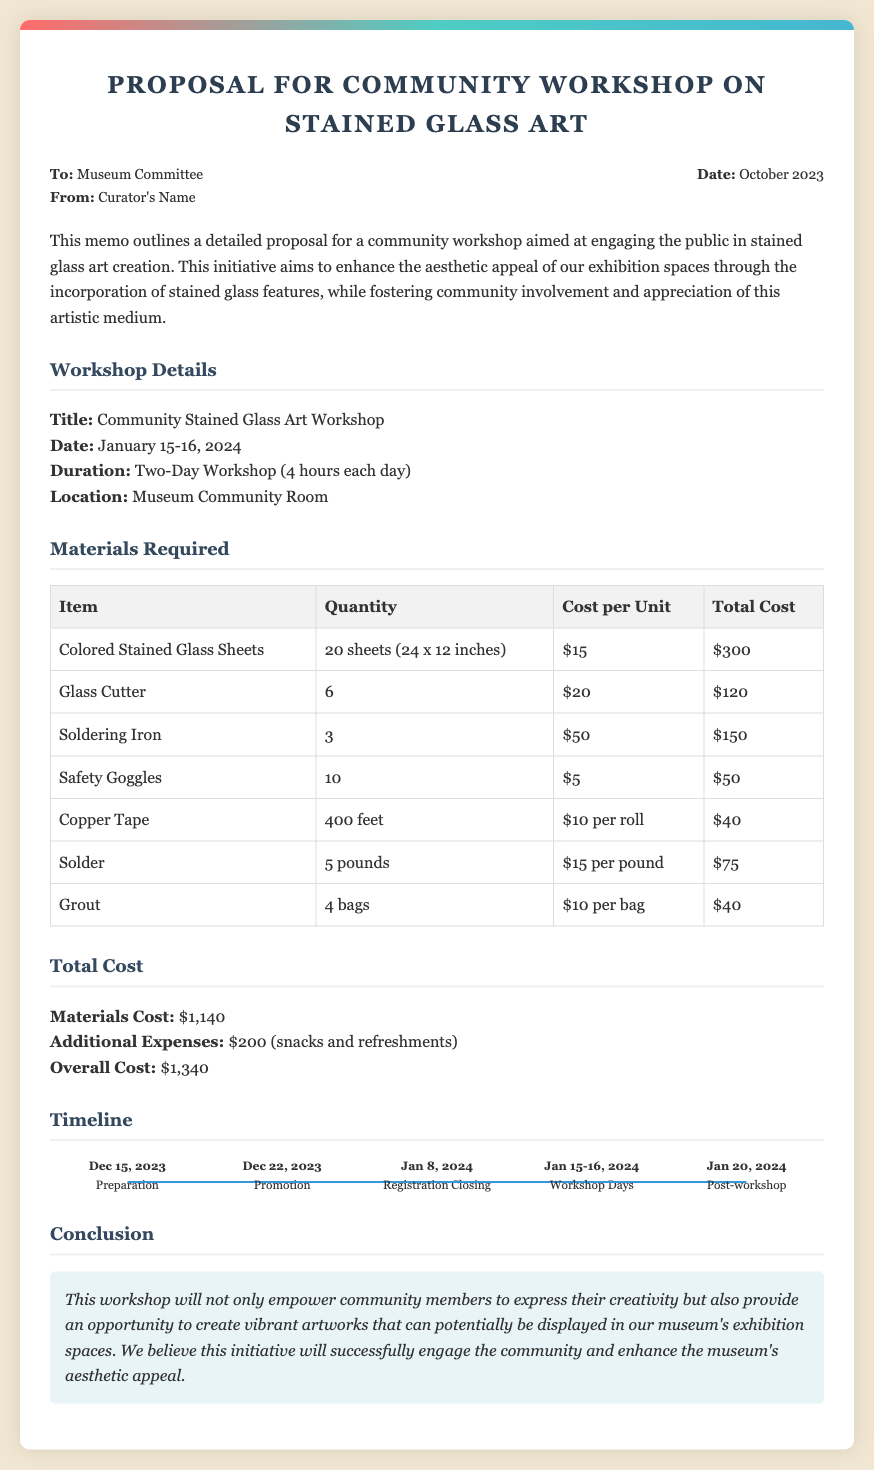what is the title of the workshop? The title of the workshop is explicitly stated in the details section of the document.
Answer: Community Stained Glass Art Workshop what are the workshop dates? The document specifies the dates of the workshop under the workshop details section.
Answer: January 15-16, 2024 how many sheets of stained glass are required? The quantity of colored stained glass sheets needed is listed in the materials required section of the document.
Answer: 20 sheets (24 x 12 inches) what is the total cost of materials? The total cost of materials is provided in the cost section of the document.
Answer: $1,140 when does registration close? The date when registration closes is mentioned in the timeline section of the document.
Answer: January 8, 2024 what is the additional expense for the workshop? The document includes a breakdown of additional expenses in the total cost section.
Answer: $200 (snacks and refreshments) how long is the duration of the workshop? The duration of the workshop is clearly stated in the workshop details section.
Answer: Two-Day Workshop (4 hours each day) which room will the workshop be held in? The location of the workshop is specified in the workshop details section of the memo.
Answer: Museum Community Room what is the overall cost of the workshop? The overall cost is detailed in the total cost section of the document.
Answer: $1,340 